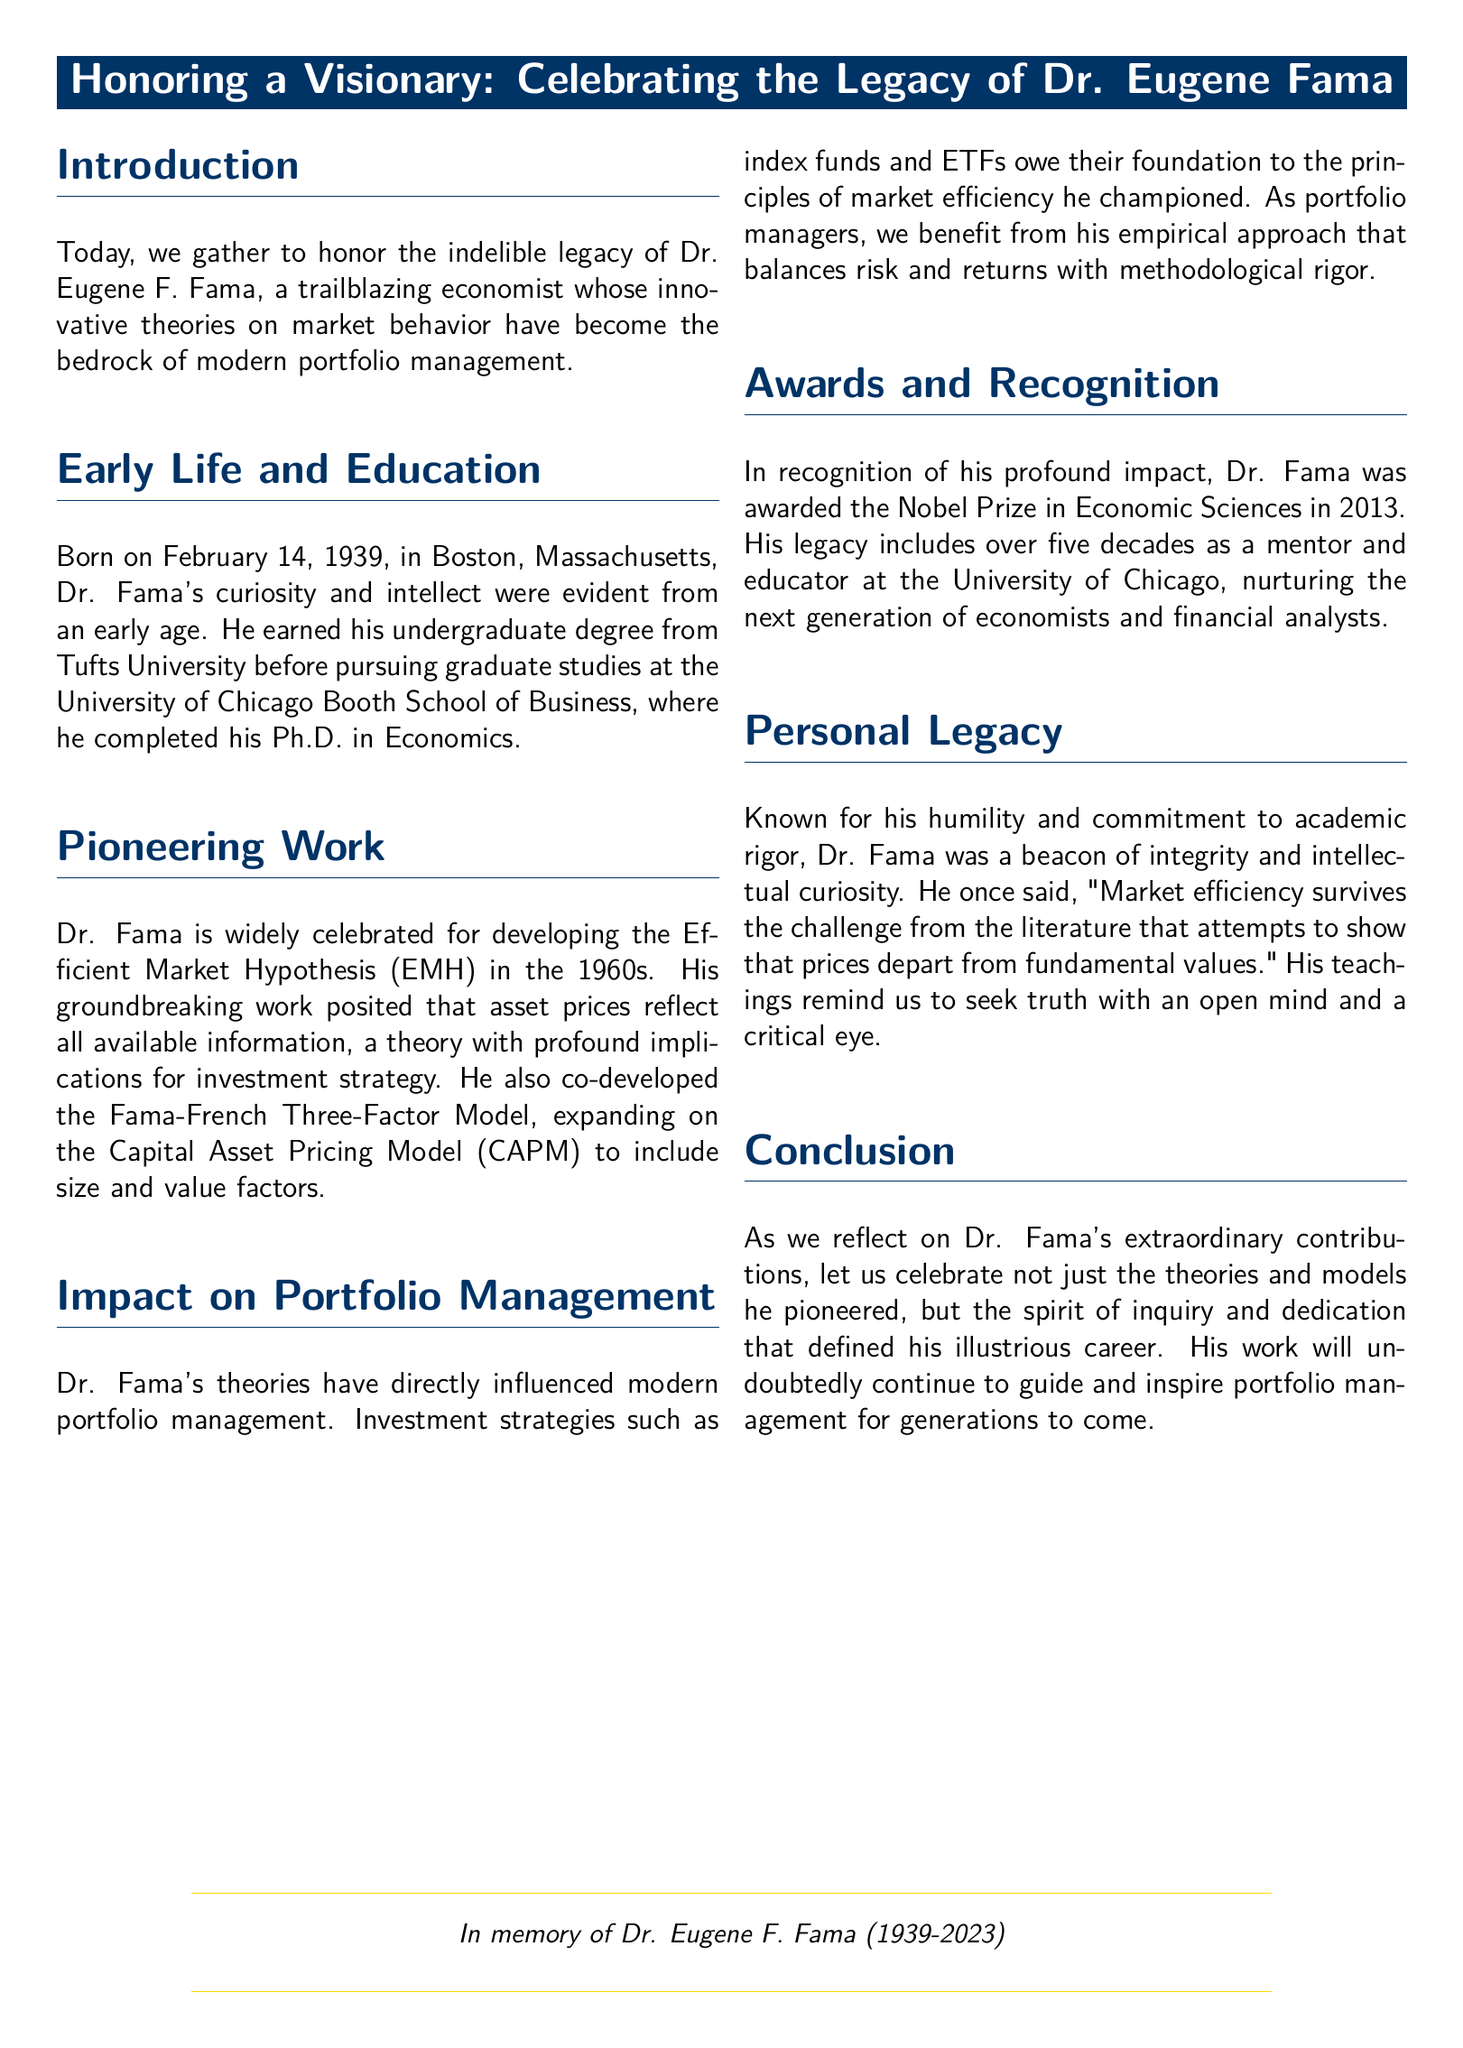What date was Dr. Fama born? The document states that Dr. Fama was born on February 14, 1939.
Answer: February 14, 1939 What theory did Dr. Fama develop in the 1960s? The document mentions that Dr. Fama developed the Efficient Market Hypothesis (EMH) in the 1960s.
Answer: Efficient Market Hypothesis (EMH) What prestigious award did Dr. Fama receive in 2013? The document notes that Dr. Fama was awarded the Nobel Prize in Economic Sciences in 2013.
Answer: Nobel Prize in Economic Sciences What is the name of the model co-developed by Dr. Fama? The document indicates that Dr. Fama co-developed the Fama-French Three-Factor Model.
Answer: Fama-French Three-Factor Model How many decades did Dr. Fama serve as a mentor and educator at the University of Chicago? The document states that Dr. Fama had over five decades as a mentor and educator at the University of Chicago.
Answer: Five decades What quality is highlighted about Dr. Fama’s character in the eulogy? The document describes Dr. Fama as known for his humility and commitment to academic rigor.
Answer: Humility and commitment to academic rigor What impact did Dr. Fama’s theories have on investment strategies? The document explains that Dr. Fama's theories influenced investment strategies such as index funds and ETFs.
Answer: Index funds and ETFs In what year did Dr. Fama pass away? The document notes the passing year of Dr. Fama as 2023.
Answer: 2023 What was the main focus of Dr. Fama's work? The eulogy states that Dr. Fama's pioneering work focused on market behavior and efficiency.
Answer: Market behavior and efficiency 